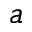<formula> <loc_0><loc_0><loc_500><loc_500>a</formula> 